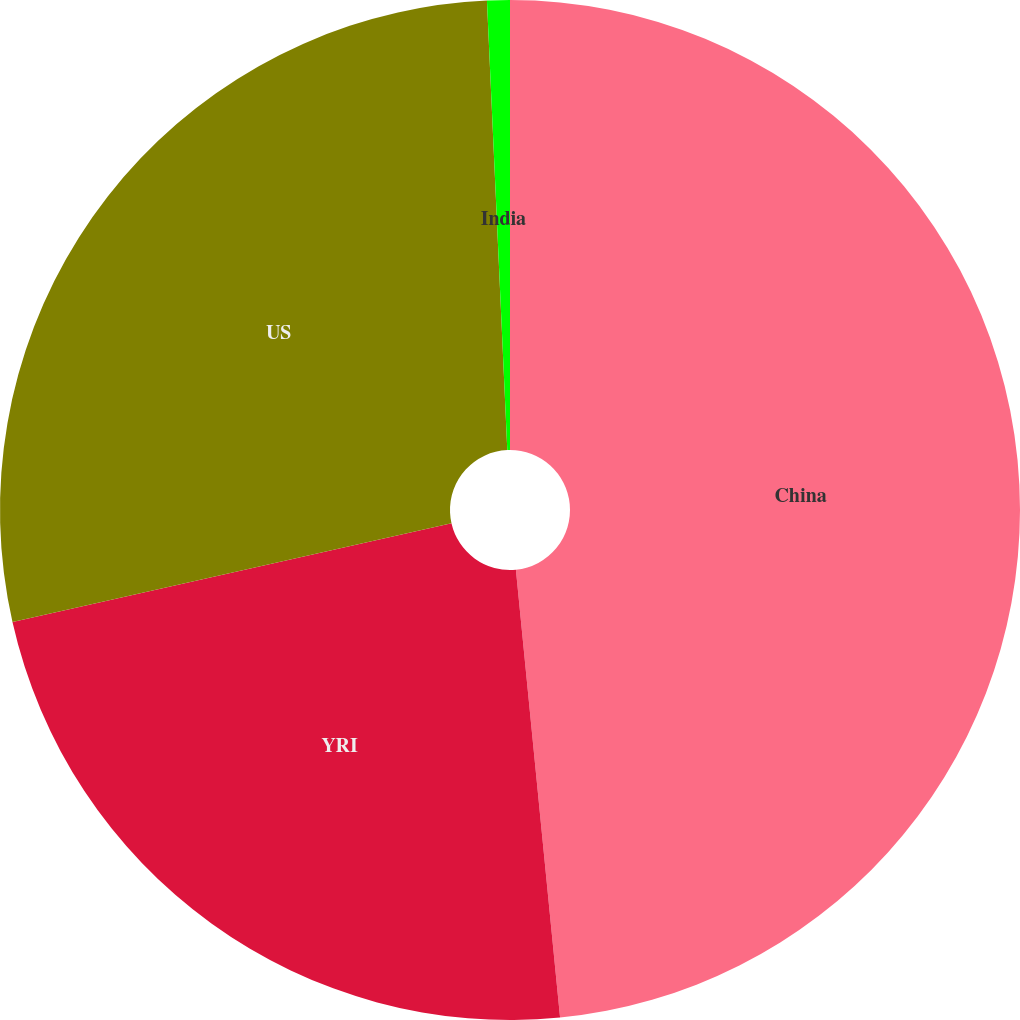<chart> <loc_0><loc_0><loc_500><loc_500><pie_chart><fcel>China<fcel>YRI<fcel>US<fcel>India<nl><fcel>48.44%<fcel>23.04%<fcel>27.81%<fcel>0.72%<nl></chart> 